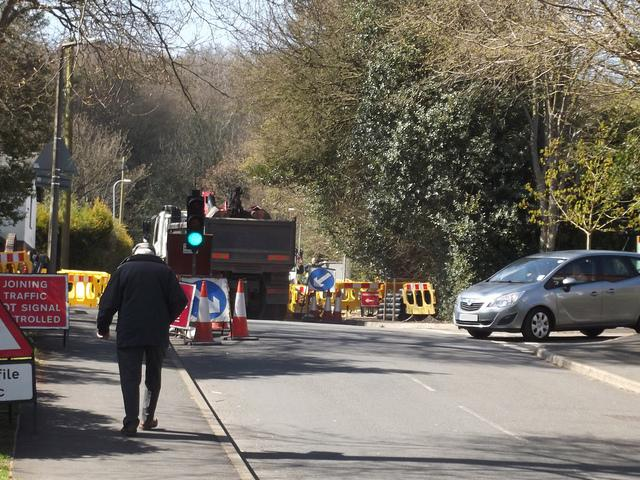What is the possible danger that will occur in the scene? Please explain your reasoning. wrong signal. The danger is the wrong signal. 